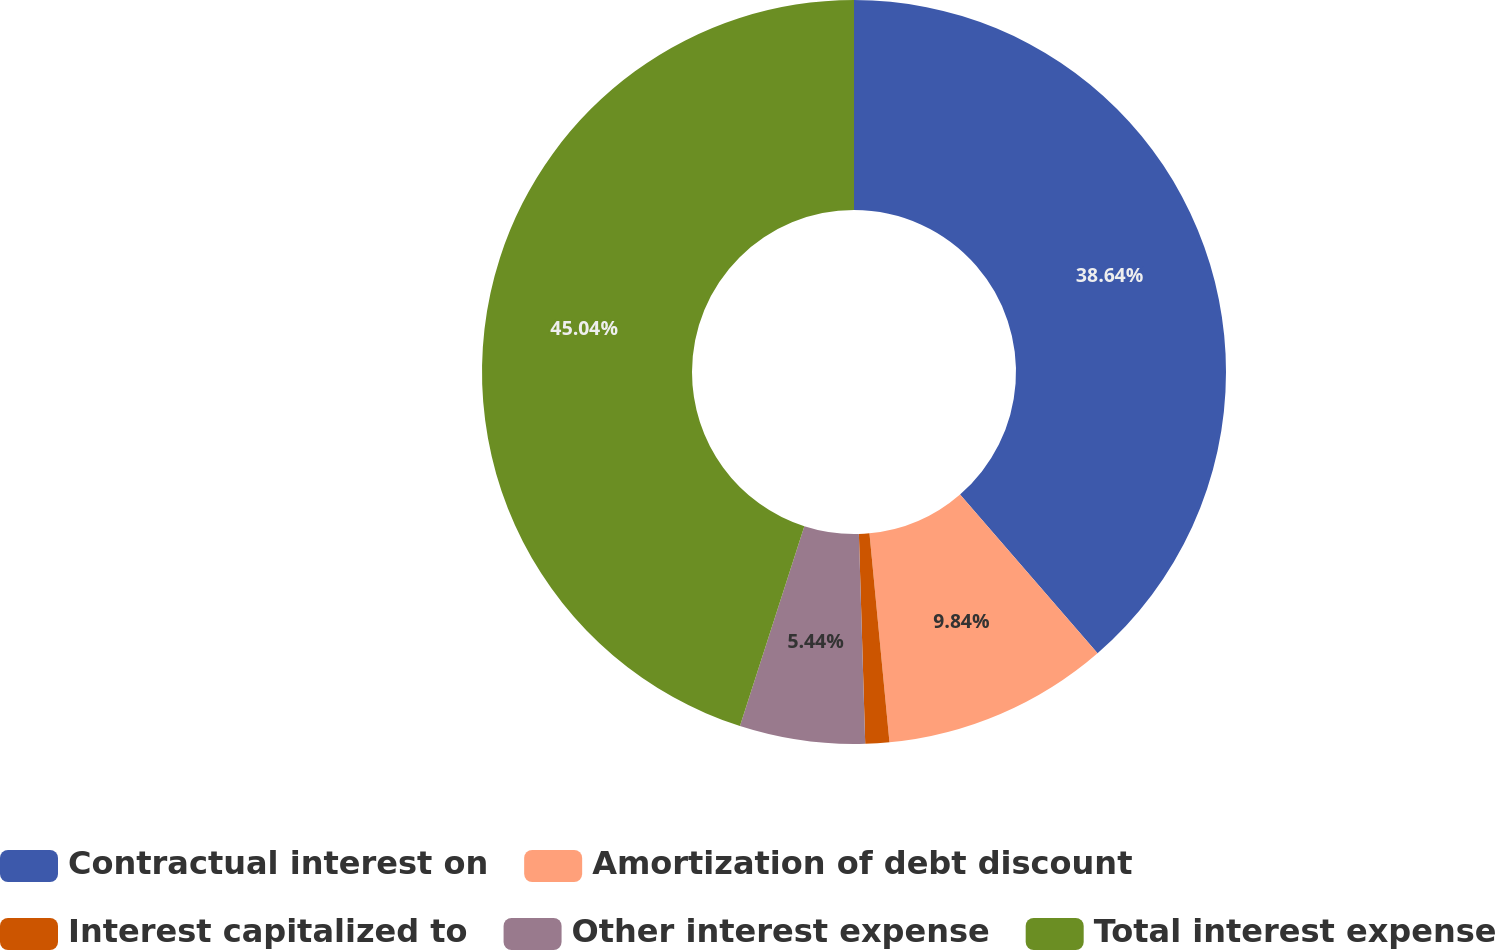Convert chart to OTSL. <chart><loc_0><loc_0><loc_500><loc_500><pie_chart><fcel>Contractual interest on<fcel>Amortization of debt discount<fcel>Interest capitalized to<fcel>Other interest expense<fcel>Total interest expense<nl><fcel>38.64%<fcel>9.84%<fcel>1.04%<fcel>5.44%<fcel>45.04%<nl></chart> 